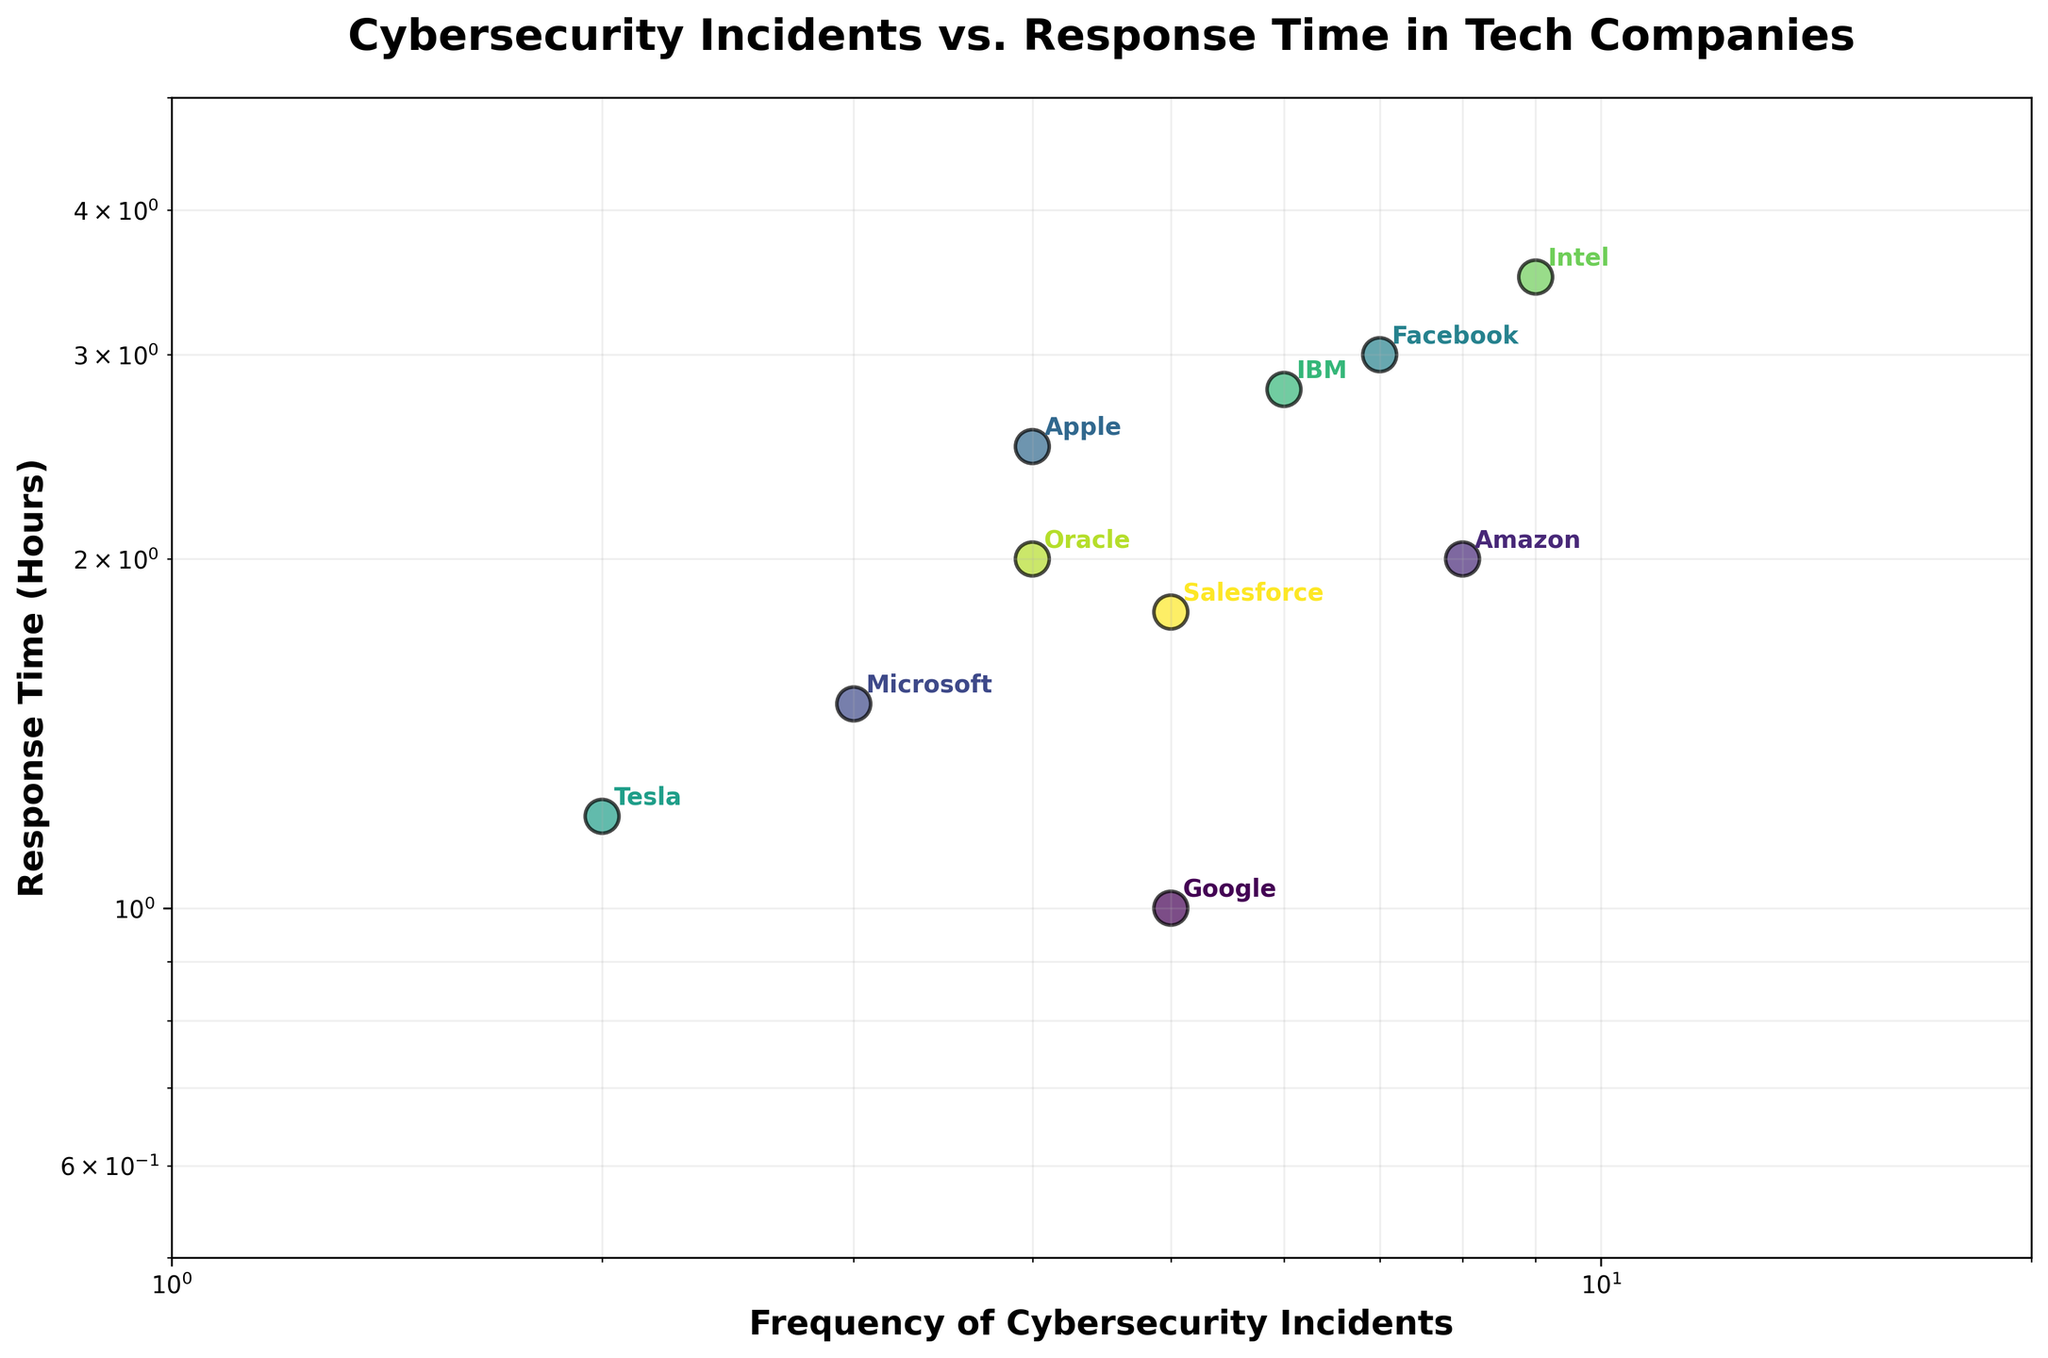What's the title of the figure? The title of the figure is typically displayed at the top in bold text. Based on the common styling of a plot, the title should be clear and should summarize what the chart is about.
Answer: Cybersecurity Incidents vs. Response Time in Tech Companies Which company has the lowest frequency of cybersecurity incidents? To find the company with the lowest frequency of cybersecurity incidents, look at the x-axis values and find the data point that is closest to the left end, then check which company it belongs to.
Answer: Tesla What is the response time for Google? Locate the data point that represents Google. Follow the point vertically to the y-axis to determine the response time.
Answer: 1 hour What is the sum of the frequencies of cybersecurity incidents for Amazon and Facebook? Locate the data points for Amazon and Facebook. Find their x-axis values which are 8 and 7 respectively, then sum these values together.
Answer: 15 Which two companies have the same response time of 2 hours? Identify the data points on the scatter plot that have y-axis values of 2. Then, check which companies these data points belong to.
Answer: Amazon and Oracle How does IBM's frequency of cybersecurity incidents compare to Intel's? Locate the data points for IBM and Intel. Compare their x-axis values to determine which is greater.
Answer: IBM has fewer incidents than Intel What range are the x-axis and y-axis values set to? Look at the x-axis and y-axis of the plot. Check the minimum and maximum values that contain the data points.
Answer: x-axis: 1 to 20, y-axis: 0.5 to 5 What is the median frequency of cybersecurity incidents across all companies? List all frequencies: 5, 8, 3, 4, 7, 2, 6, 9, 4, 5. Sort them to 2, 3, 4, 4, 5, 5, 6, 7, 8, 9. The median will be the middle value of this sorted list.
Answer: 5 Does any company have a response time exactly at the midpoint of 1.5 hours? Look for any data point that aligns with the 1.5 mark on the y-axis. Check which company corresponds to it.
Answer: Microsoft 